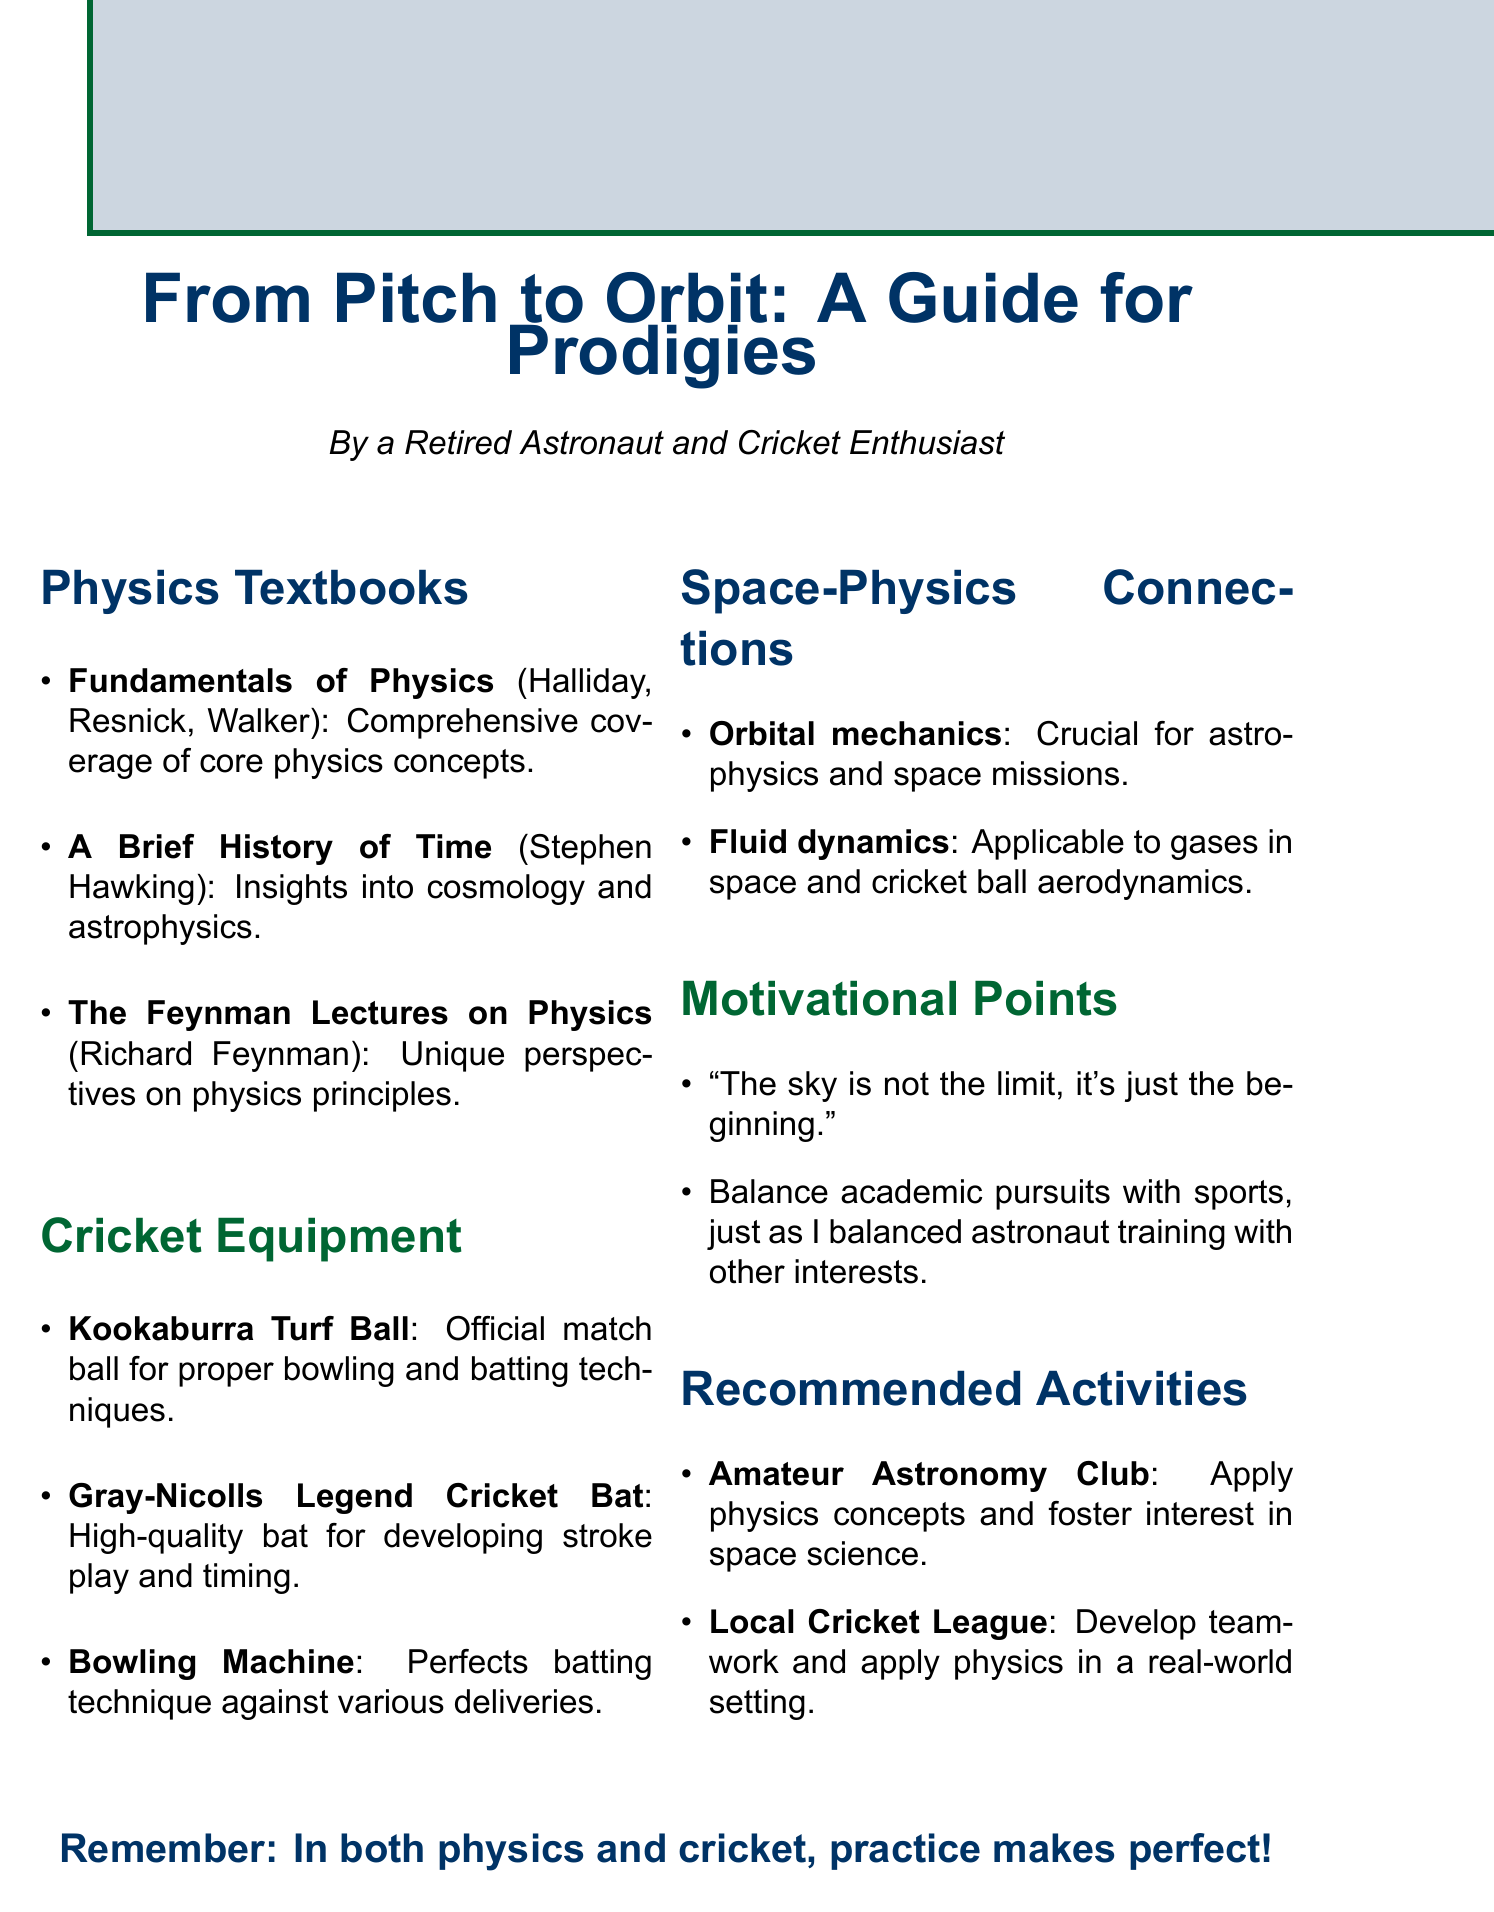What is the title of the first recommended physics textbook? The title of the first recommended physics textbook is essential to identify core learning materials.
Answer: Fundamentals of Physics Who is the author of "A Brief History of Time"? Knowing the author helps in understanding the credibility and perspective of the book.
Answer: Stephen Hawking What cricket equipment is used for developing proper bowling and batting techniques? Identifying specific equipment can guide students in effective training practices.
Answer: Kookaburra Turf Ball Which space-physics connection relates to planetary motion? Understanding connections between space concepts and physics can enhance appreciation for both fields.
Answer: Orbital mechanics What motivational quote is included in the document? Quotes can inspire students and provide motivation to pursue their passions in science and sports.
Answer: The sky is not the limit, it's just the beginning Which extracurricular activity is related to applying physics concepts? Recognizing extracurricular options can encourage practical learning and engagement with physics.
Answer: Amateur Astronomy Club 